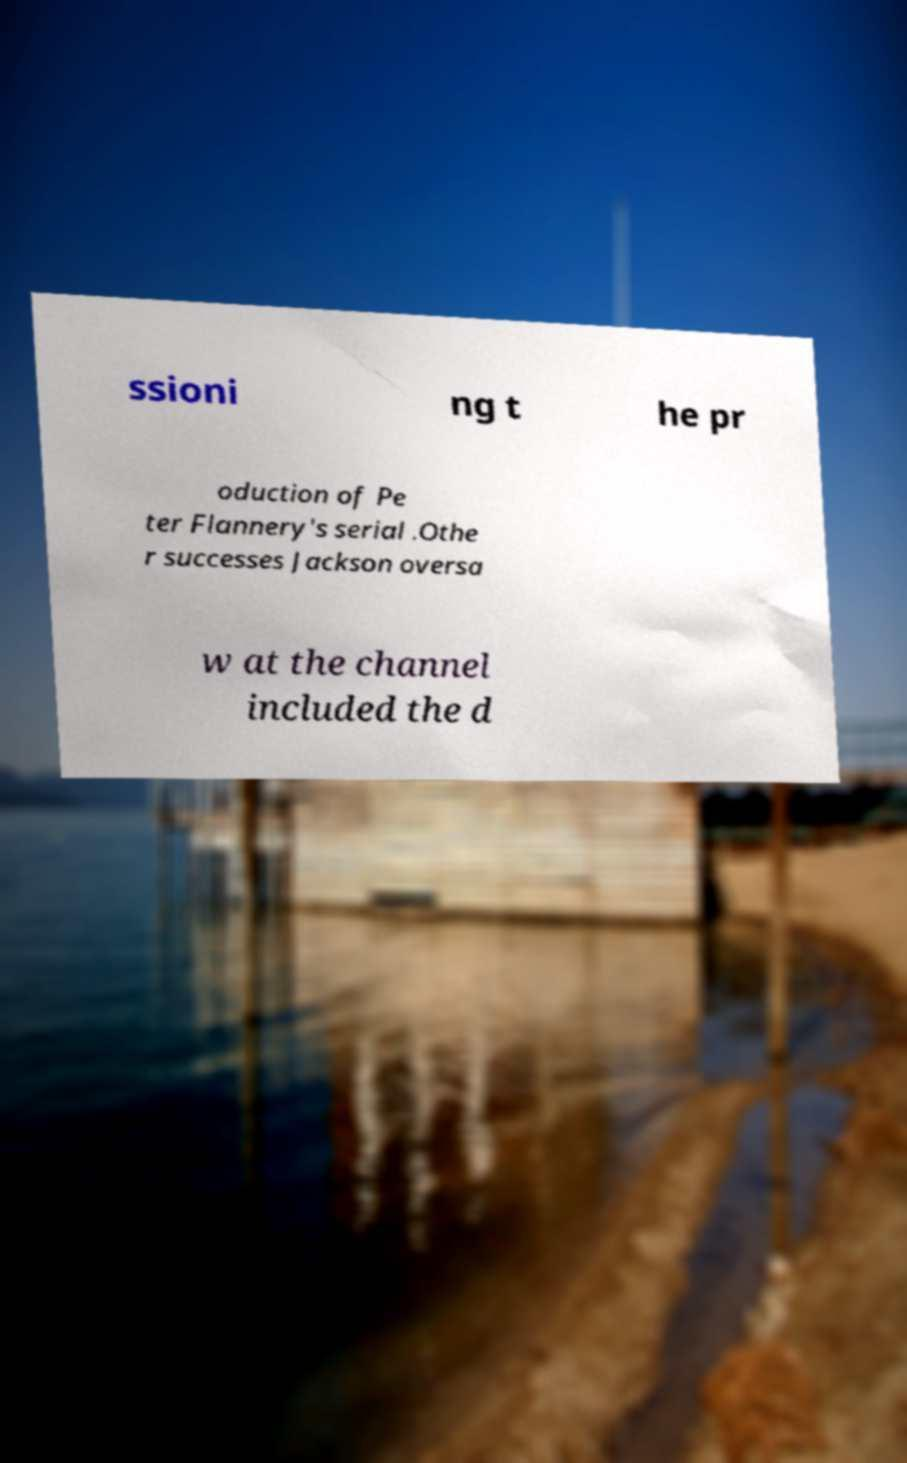What messages or text are displayed in this image? I need them in a readable, typed format. ssioni ng t he pr oduction of Pe ter Flannery's serial .Othe r successes Jackson oversa w at the channel included the d 